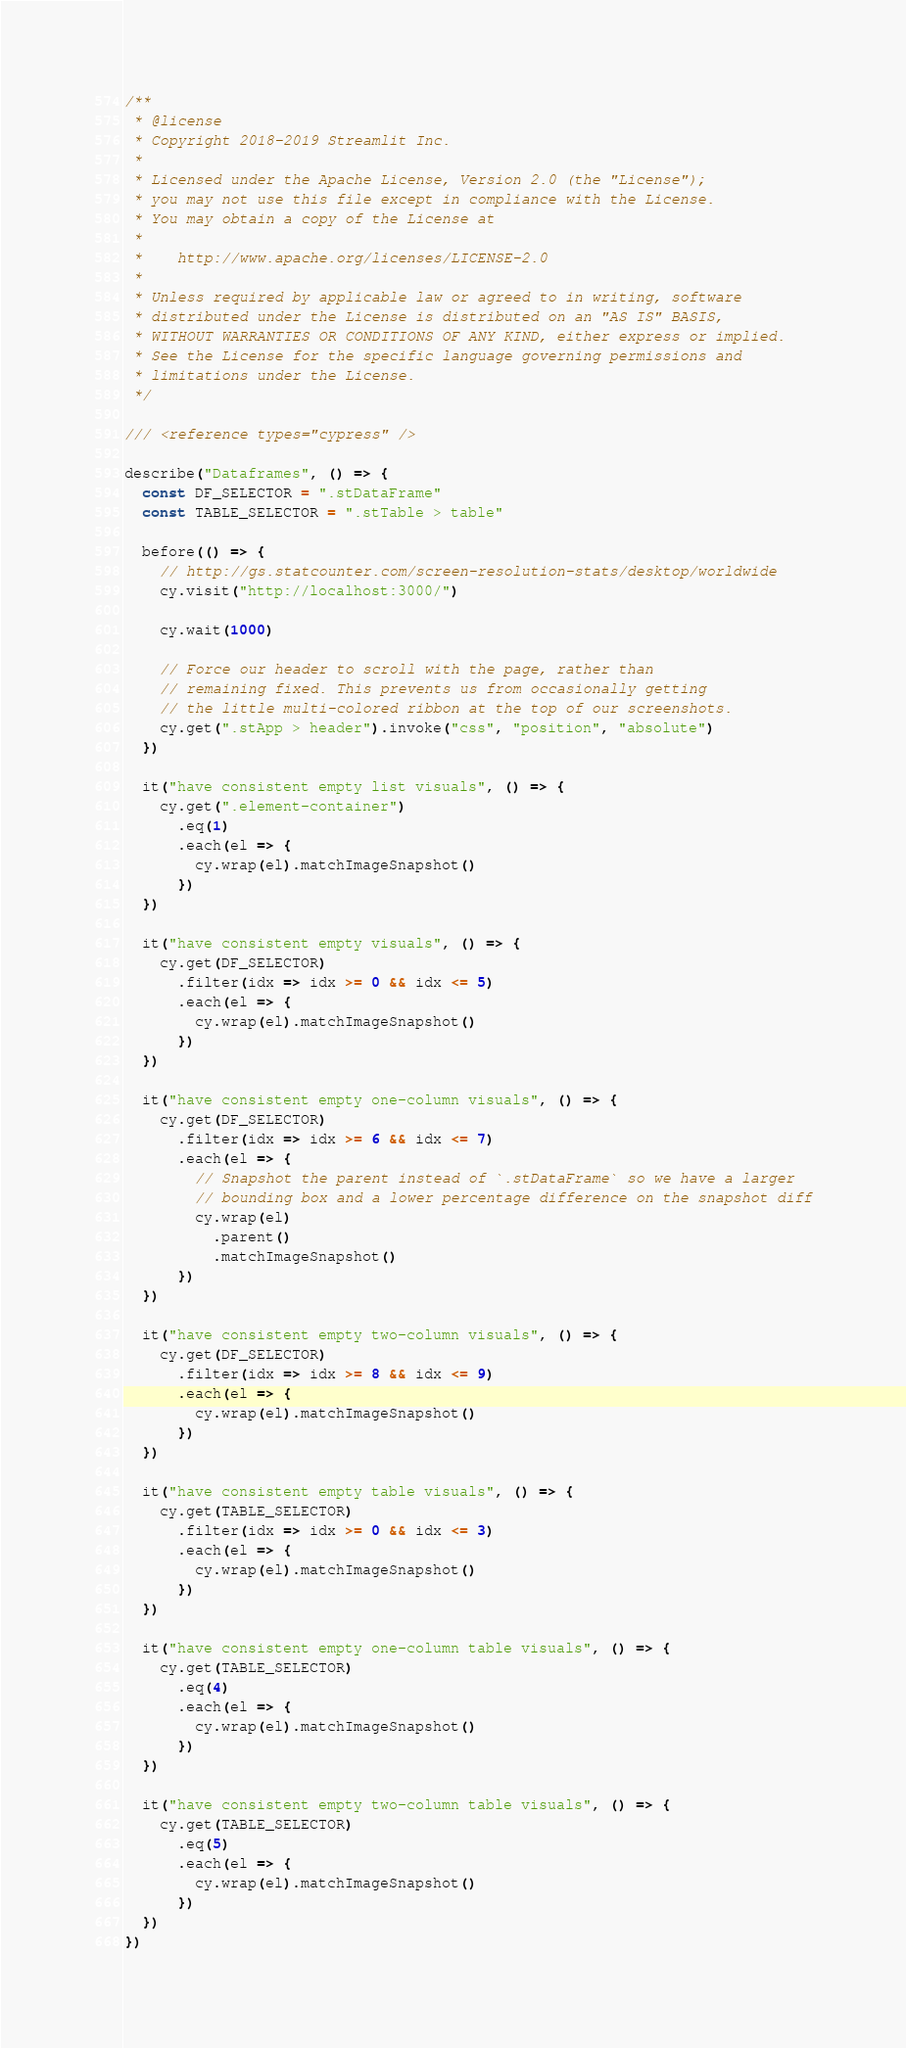<code> <loc_0><loc_0><loc_500><loc_500><_TypeScript_>/**
 * @license
 * Copyright 2018-2019 Streamlit Inc.
 *
 * Licensed under the Apache License, Version 2.0 (the "License");
 * you may not use this file except in compliance with the License.
 * You may obtain a copy of the License at
 *
 *    http://www.apache.org/licenses/LICENSE-2.0
 *
 * Unless required by applicable law or agreed to in writing, software
 * distributed under the License is distributed on an "AS IS" BASIS,
 * WITHOUT WARRANTIES OR CONDITIONS OF ANY KIND, either express or implied.
 * See the License for the specific language governing permissions and
 * limitations under the License.
 */

/// <reference types="cypress" />

describe("Dataframes", () => {
  const DF_SELECTOR = ".stDataFrame"
  const TABLE_SELECTOR = ".stTable > table"

  before(() => {
    // http://gs.statcounter.com/screen-resolution-stats/desktop/worldwide
    cy.visit("http://localhost:3000/")

    cy.wait(1000)

    // Force our header to scroll with the page, rather than
    // remaining fixed. This prevents us from occasionally getting
    // the little multi-colored ribbon at the top of our screenshots.
    cy.get(".stApp > header").invoke("css", "position", "absolute")
  })

  it("have consistent empty list visuals", () => {
    cy.get(".element-container")
      .eq(1)
      .each(el => {
        cy.wrap(el).matchImageSnapshot()
      })
  })

  it("have consistent empty visuals", () => {
    cy.get(DF_SELECTOR)
      .filter(idx => idx >= 0 && idx <= 5)
      .each(el => {
        cy.wrap(el).matchImageSnapshot()
      })
  })

  it("have consistent empty one-column visuals", () => {
    cy.get(DF_SELECTOR)
      .filter(idx => idx >= 6 && idx <= 7)
      .each(el => {
        // Snapshot the parent instead of `.stDataFrame` so we have a larger
        // bounding box and a lower percentage difference on the snapshot diff
        cy.wrap(el)
          .parent()
          .matchImageSnapshot()
      })
  })

  it("have consistent empty two-column visuals", () => {
    cy.get(DF_SELECTOR)
      .filter(idx => idx >= 8 && idx <= 9)
      .each(el => {
        cy.wrap(el).matchImageSnapshot()
      })
  })

  it("have consistent empty table visuals", () => {
    cy.get(TABLE_SELECTOR)
      .filter(idx => idx >= 0 && idx <= 3)
      .each(el => {
        cy.wrap(el).matchImageSnapshot()
      })
  })

  it("have consistent empty one-column table visuals", () => {
    cy.get(TABLE_SELECTOR)
      .eq(4)
      .each(el => {
        cy.wrap(el).matchImageSnapshot()
      })
  })

  it("have consistent empty two-column table visuals", () => {
    cy.get(TABLE_SELECTOR)
      .eq(5)
      .each(el => {
        cy.wrap(el).matchImageSnapshot()
      })
  })
})
</code> 